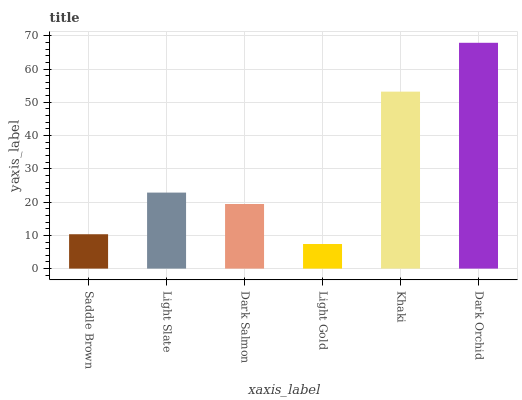Is Light Slate the minimum?
Answer yes or no. No. Is Light Slate the maximum?
Answer yes or no. No. Is Light Slate greater than Saddle Brown?
Answer yes or no. Yes. Is Saddle Brown less than Light Slate?
Answer yes or no. Yes. Is Saddle Brown greater than Light Slate?
Answer yes or no. No. Is Light Slate less than Saddle Brown?
Answer yes or no. No. Is Light Slate the high median?
Answer yes or no. Yes. Is Dark Salmon the low median?
Answer yes or no. Yes. Is Dark Orchid the high median?
Answer yes or no. No. Is Light Slate the low median?
Answer yes or no. No. 